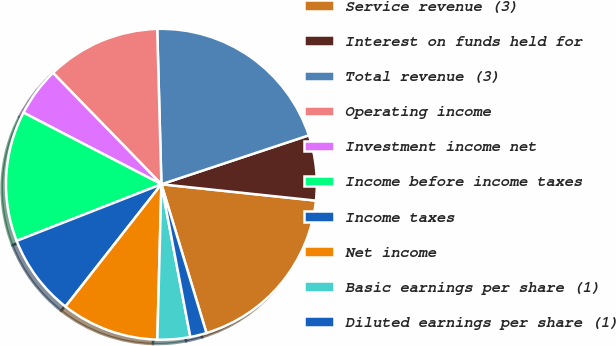Convert chart to OTSL. <chart><loc_0><loc_0><loc_500><loc_500><pie_chart><fcel>Service revenue (3)<fcel>Interest on funds held for<fcel>Total revenue (3)<fcel>Operating income<fcel>Investment income net<fcel>Income before income taxes<fcel>Income taxes<fcel>Net income<fcel>Basic earnings per share (1)<fcel>Diluted earnings per share (1)<nl><fcel>18.64%<fcel>6.78%<fcel>20.33%<fcel>11.86%<fcel>5.09%<fcel>13.56%<fcel>8.48%<fcel>10.17%<fcel>3.4%<fcel>1.7%<nl></chart> 